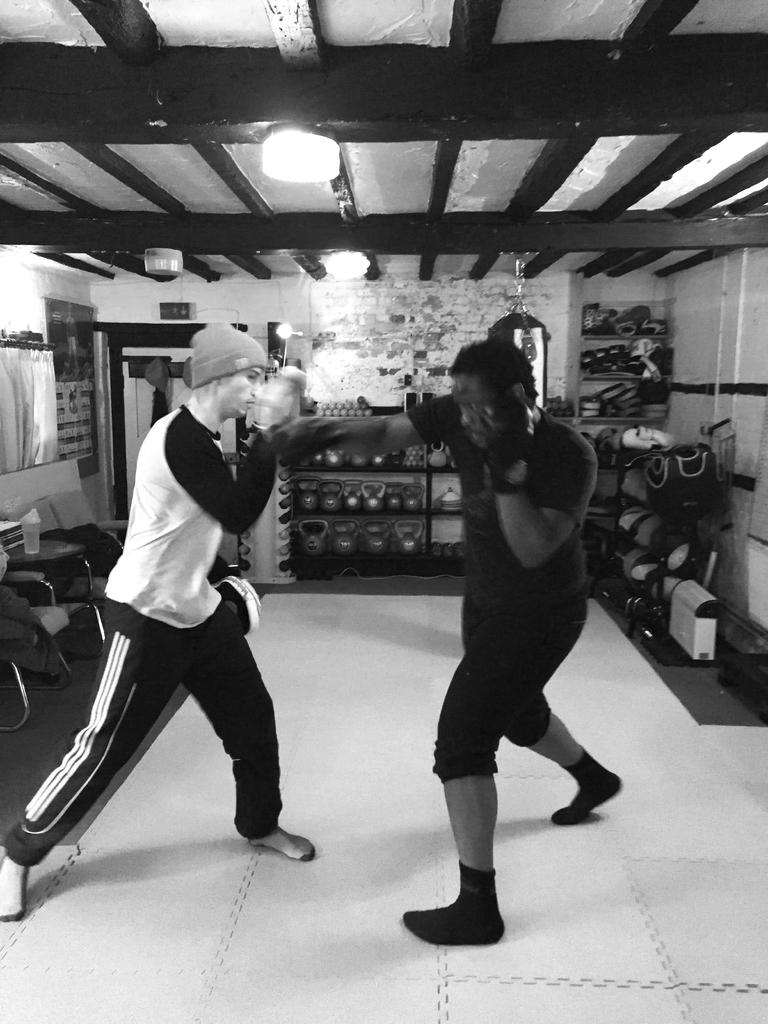What activity are the men in the image engaged in? The men in the image are practicing boxing. Can you describe the attire of one of the men? One man is wearing a cap. What type of furniture can be seen in the image? There are shelves, chairs, and a table in the image. What equipment is used for boxing practice in the image? There is a boxing bag in the image. Is there any beverage or liquid container present in the image? Yes, there is a bottle on a table in the image. How deep is the hole that the men are digging in the image? There is no hole present in the image; the men are practicing boxing. 